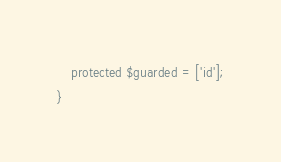Convert code to text. <code><loc_0><loc_0><loc_500><loc_500><_PHP_>    protected $guarded = ['id'];
}
</code> 